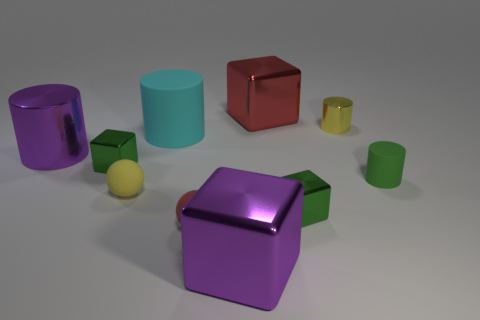Are there fewer rubber cylinders that are behind the big red shiny object than purple blocks?
Give a very brief answer. Yes. What number of small metal cubes are on the left side of the red metal block?
Offer a very short reply. 1. Does the big purple thing that is behind the large purple metal cube have the same shape as the small green shiny thing to the right of the large red thing?
Keep it short and to the point. No. There is a metallic thing that is both in front of the big metal cylinder and on the left side of the small yellow rubber thing; what is its shape?
Provide a succinct answer. Cube. There is a cyan cylinder that is the same material as the yellow sphere; what size is it?
Offer a terse response. Large. Are there fewer purple metal blocks than gray matte balls?
Offer a very short reply. No. What material is the large cube that is in front of the purple metallic thing behind the object in front of the red rubber object made of?
Your answer should be compact. Metal. Do the red object that is behind the big cyan matte cylinder and the large purple thing that is behind the big purple block have the same material?
Give a very brief answer. Yes. How big is the matte thing that is both on the left side of the tiny red rubber ball and in front of the large cyan rubber thing?
Your answer should be compact. Small. There is a yellow cylinder that is the same size as the yellow ball; what material is it?
Your answer should be very brief. Metal. 